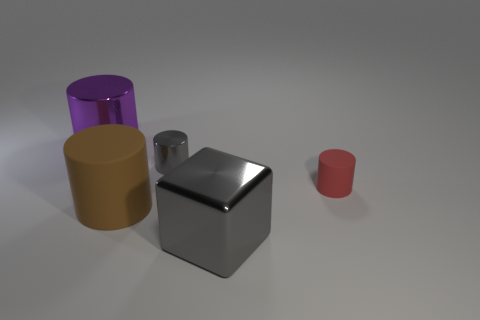Subtract all brown matte cylinders. How many cylinders are left? 3 Add 1 small purple metallic balls. How many objects exist? 6 Subtract 1 cylinders. How many cylinders are left? 3 Subtract all red cylinders. How many cylinders are left? 3 Add 5 cubes. How many cubes exist? 6 Subtract 0 gray balls. How many objects are left? 5 Subtract all cylinders. How many objects are left? 1 Subtract all green cylinders. Subtract all purple balls. How many cylinders are left? 4 Subtract all tiny gray matte blocks. Subtract all red cylinders. How many objects are left? 4 Add 4 tiny red matte things. How many tiny red matte things are left? 5 